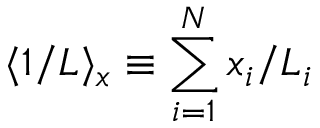<formula> <loc_0><loc_0><loc_500><loc_500>\langle 1 / L \rangle _ { x } \equiv \sum _ { i = 1 } ^ { N } x _ { i } / L _ { i }</formula> 